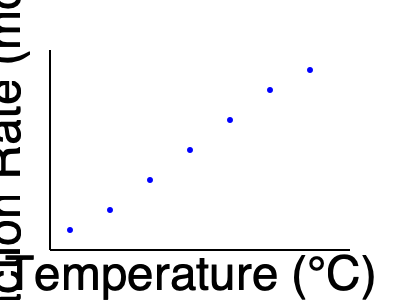As a scientist analyzing the effect of temperature on a chemical reaction, you've collected data on reaction rates at various temperatures. The scatter plot shows the relationship between temperature and reaction rate. Based on this data, what type of correlation exists between temperature and reaction rate, and what does this suggest about the nature of the reaction? To analyze the correlation between temperature and reaction rate, we need to follow these steps:

1. Observe the overall trend in the scatter plot:
   The points show a clear upward trend from left to right.

2. Assess the direction of the relationship:
   As temperature increases, the reaction rate also increases.

3. Evaluate the strength of the relationship:
   The points form a relatively tight pattern around an imaginary line, indicating a strong relationship.

4. Determine the type of correlation:
   The relationship appears to be positive and strong.

5. Analyze the shape of the trend:
   The increase is not perfectly linear; there's a slight curve, with the rate of increase becoming less steep at higher temperatures.

6. Interpret the results in the context of chemical kinetics:
   This pattern is consistent with the Arrhenius equation: $k = Ae^{-E_a/RT}$
   Where:
   $k$ is the reaction rate constant
   $A$ is the pre-exponential factor
   $E_a$ is the activation energy
   $R$ is the gas constant
   $T$ is the temperature in Kelvin

7. Draw conclusions about the nature of the reaction:
   The positive correlation suggests that the reaction is endothermic, requiring heat input to proceed.
   The slight curvature indicates that the reaction rate doesn't increase indefinitely with temperature, which is consistent with real-world chemical kinetics.
Answer: Strong positive correlation; endothermic reaction following Arrhenius kinetics. 